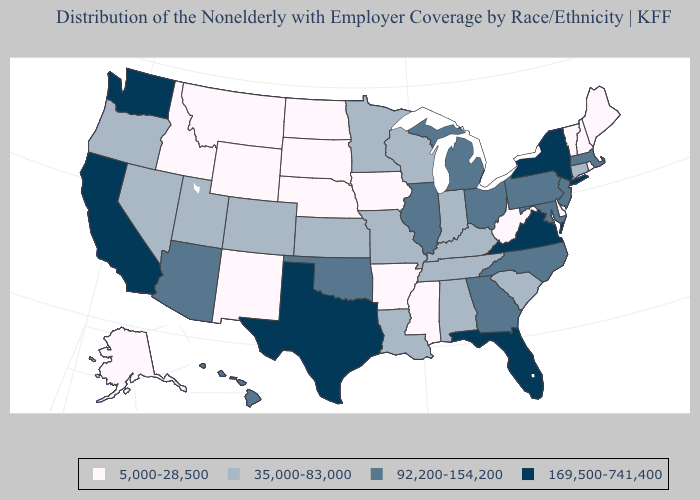What is the lowest value in the Northeast?
Give a very brief answer. 5,000-28,500. Name the states that have a value in the range 169,500-741,400?
Answer briefly. California, Florida, New York, Texas, Virginia, Washington. What is the lowest value in states that border Utah?
Be succinct. 5,000-28,500. Name the states that have a value in the range 35,000-83,000?
Concise answer only. Alabama, Colorado, Connecticut, Indiana, Kansas, Kentucky, Louisiana, Minnesota, Missouri, Nevada, Oregon, South Carolina, Tennessee, Utah, Wisconsin. What is the value of Montana?
Keep it brief. 5,000-28,500. Does North Carolina have the lowest value in the USA?
Quick response, please. No. Name the states that have a value in the range 35,000-83,000?
Give a very brief answer. Alabama, Colorado, Connecticut, Indiana, Kansas, Kentucky, Louisiana, Minnesota, Missouri, Nevada, Oregon, South Carolina, Tennessee, Utah, Wisconsin. Among the states that border Illinois , which have the lowest value?
Give a very brief answer. Iowa. Does California have the highest value in the West?
Give a very brief answer. Yes. What is the value of Louisiana?
Give a very brief answer. 35,000-83,000. What is the lowest value in states that border Iowa?
Concise answer only. 5,000-28,500. Does the first symbol in the legend represent the smallest category?
Keep it brief. Yes. Does Florida have the highest value in the USA?
Give a very brief answer. Yes. Among the states that border New Hampshire , which have the lowest value?
Give a very brief answer. Maine, Vermont. 